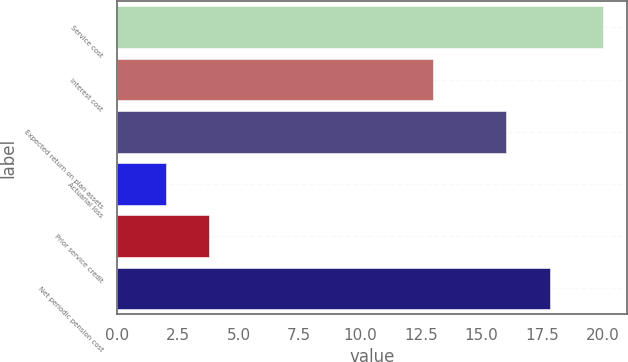Convert chart. <chart><loc_0><loc_0><loc_500><loc_500><bar_chart><fcel>Service cost<fcel>Interest cost<fcel>Expected return on plan assets<fcel>Actuarial loss<fcel>Prior service credit<fcel>Net periodic pension cost<nl><fcel>20<fcel>13<fcel>16<fcel>2<fcel>3.8<fcel>17.8<nl></chart> 